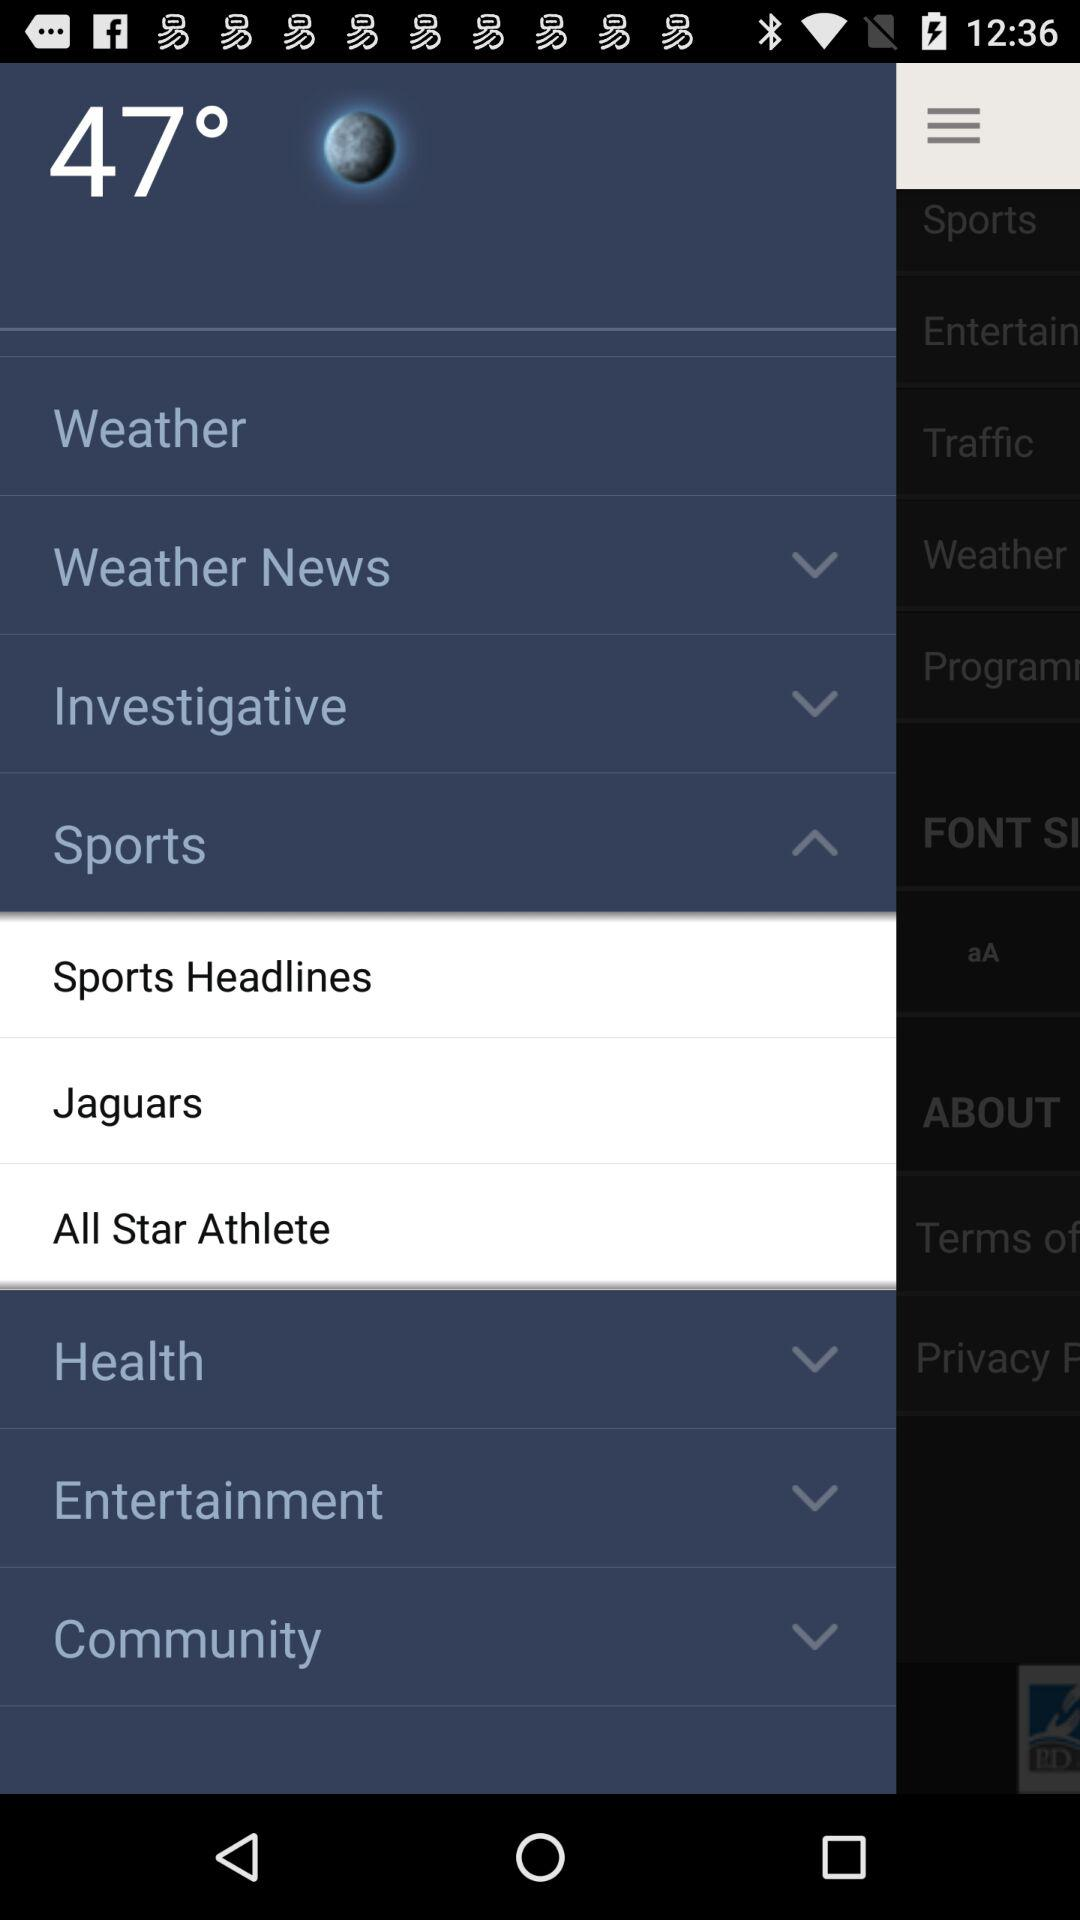What is the shown temperature? The shown temperature is 47°. 